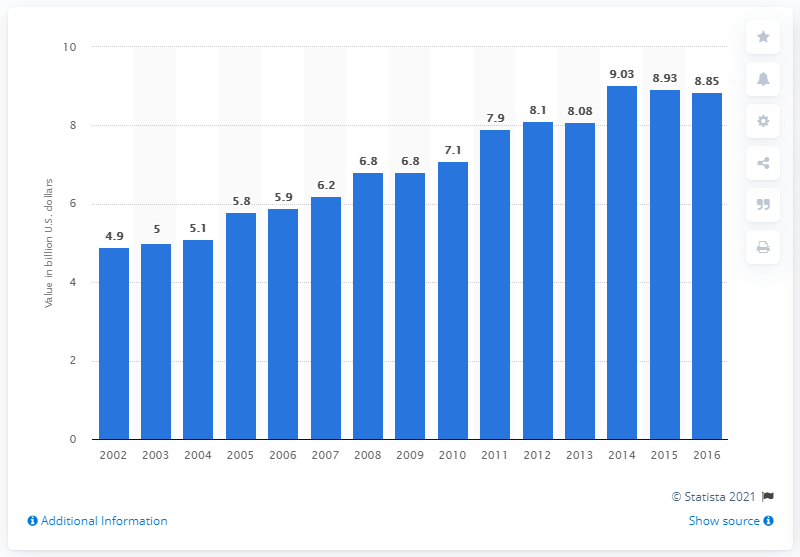Highlight a few significant elements in this photo. In 2016, the value of potato chips and sticks in the United States was 8.85. 